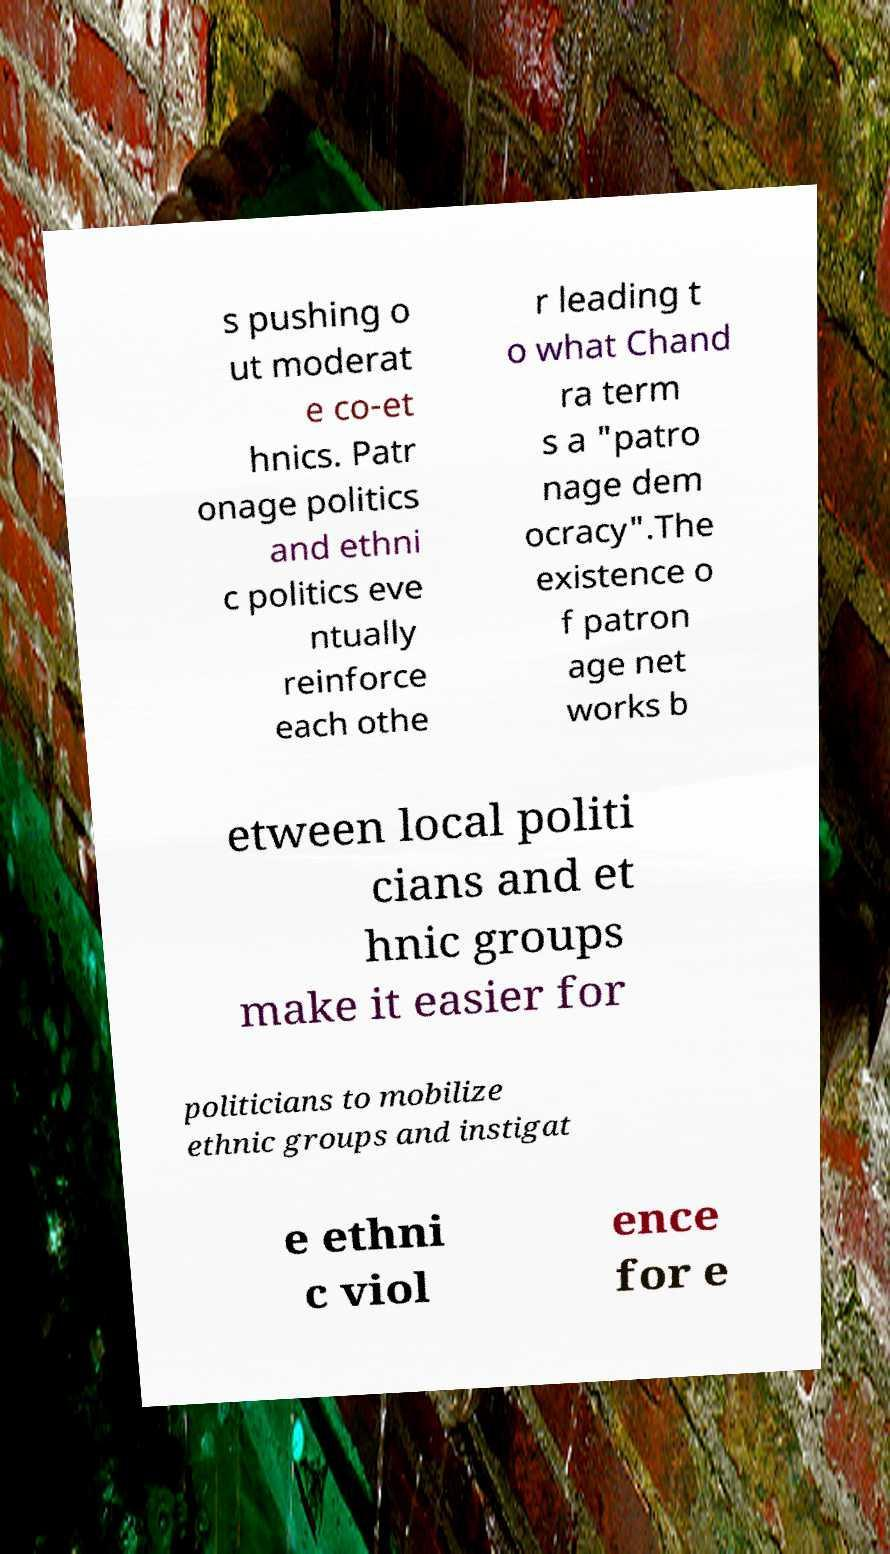Please identify and transcribe the text found in this image. s pushing o ut moderat e co-et hnics. Patr onage politics and ethni c politics eve ntually reinforce each othe r leading t o what Chand ra term s a "patro nage dem ocracy".The existence o f patron age net works b etween local politi cians and et hnic groups make it easier for politicians to mobilize ethnic groups and instigat e ethni c viol ence for e 